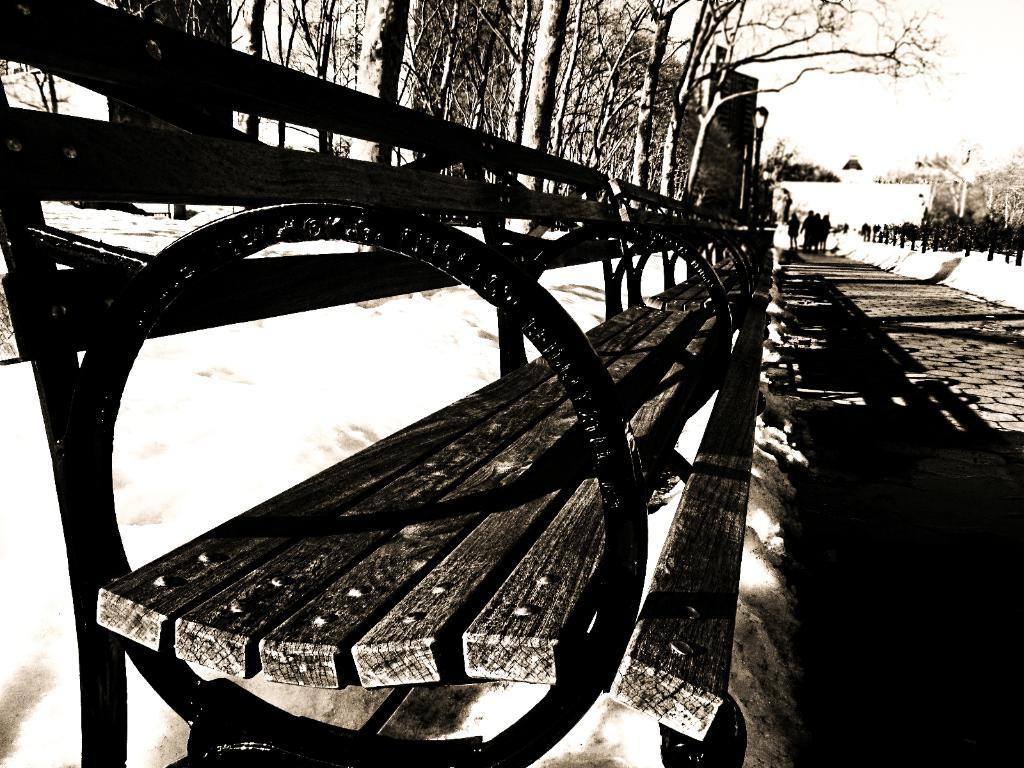What type of seating is visible in the image? There is a bench in the image. What are the people in the image doing? There are persons standing on the ground in the image. What type of vegetation is present in the image? There are trees in the image. What is the weather like in the image? There is snow in the image, indicating a cold or wintry environment. What is visible at the top of the image? The sky is visible at the top of the image. Can you tell me how many eyes are visible on the lumber in the image? There is no lumber present in the image, and therefore no eyes can be observed on it. What type of snack is being served in the image? There is no snack, such as popcorn, present in the image. 